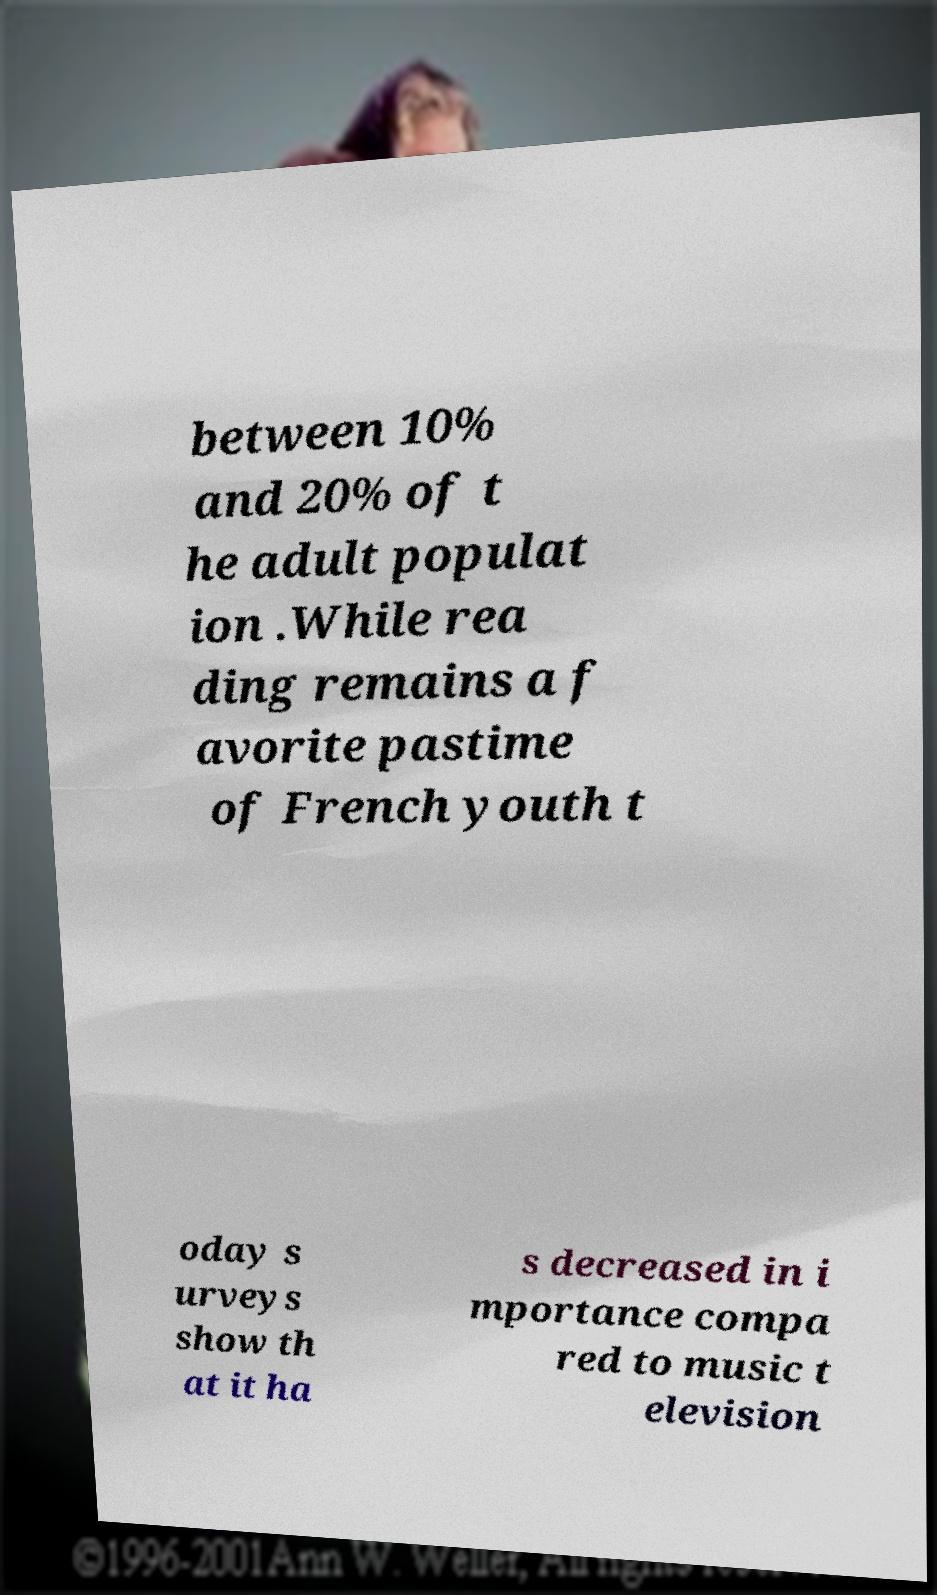I need the written content from this picture converted into text. Can you do that? between 10% and 20% of t he adult populat ion .While rea ding remains a f avorite pastime of French youth t oday s urveys show th at it ha s decreased in i mportance compa red to music t elevision 